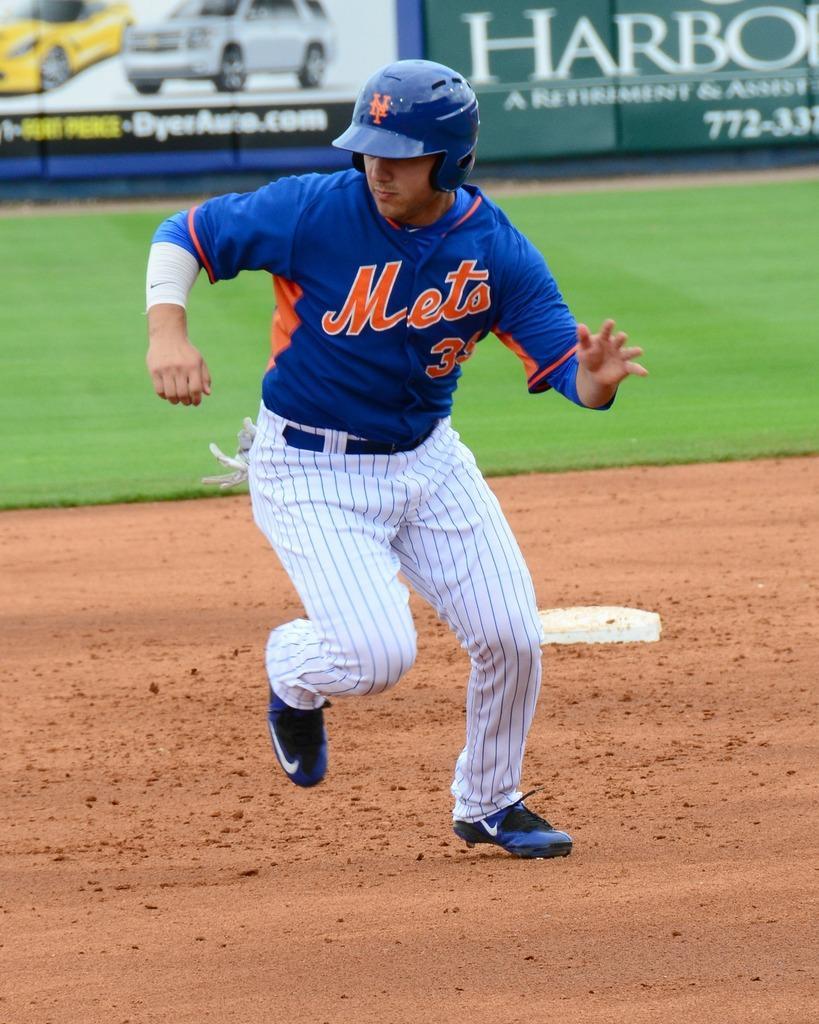In one or two sentences, can you explain what this image depicts? In this image we can see a person wearing helmet. In the back there's grass on the ground. In the background there are banners. On the banner something is written. Also we can see two cars on the banner. 